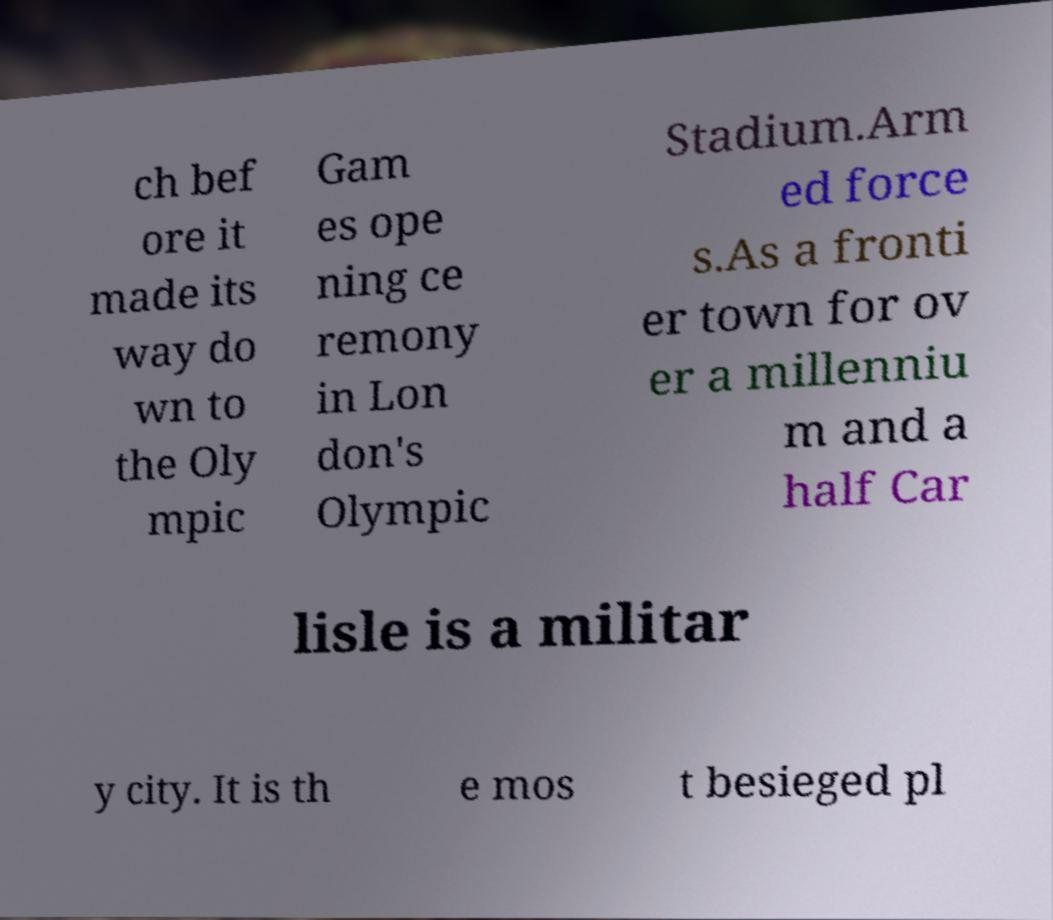There's text embedded in this image that I need extracted. Can you transcribe it verbatim? ch bef ore it made its way do wn to the Oly mpic Gam es ope ning ce remony in Lon don's Olympic Stadium.Arm ed force s.As a fronti er town for ov er a millenniu m and a half Car lisle is a militar y city. It is th e mos t besieged pl 